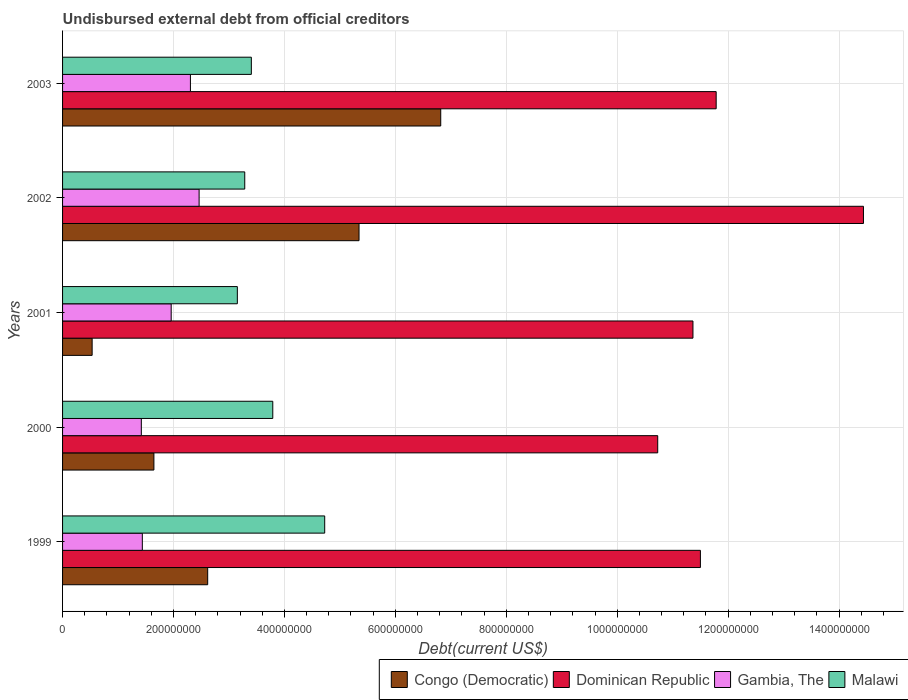How many different coloured bars are there?
Your answer should be very brief. 4. Are the number of bars per tick equal to the number of legend labels?
Provide a short and direct response. Yes. Are the number of bars on each tick of the Y-axis equal?
Provide a short and direct response. Yes. What is the label of the 3rd group of bars from the top?
Provide a short and direct response. 2001. What is the total debt in Dominican Republic in 1999?
Provide a short and direct response. 1.15e+09. Across all years, what is the maximum total debt in Congo (Democratic)?
Provide a succinct answer. 6.82e+08. Across all years, what is the minimum total debt in Malawi?
Keep it short and to the point. 3.15e+08. In which year was the total debt in Gambia, The minimum?
Offer a very short reply. 2000. What is the total total debt in Gambia, The in the graph?
Your answer should be compact. 9.58e+08. What is the difference between the total debt in Congo (Democratic) in 1999 and that in 2000?
Your response must be concise. 9.70e+07. What is the difference between the total debt in Gambia, The in 2000 and the total debt in Congo (Democratic) in 1999?
Make the answer very short. -1.20e+08. What is the average total debt in Congo (Democratic) per year?
Offer a very short reply. 3.39e+08. In the year 2001, what is the difference between the total debt in Gambia, The and total debt in Dominican Republic?
Your response must be concise. -9.41e+08. What is the ratio of the total debt in Congo (Democratic) in 1999 to that in 2003?
Keep it short and to the point. 0.38. Is the difference between the total debt in Gambia, The in 2000 and 2001 greater than the difference between the total debt in Dominican Republic in 2000 and 2001?
Make the answer very short. Yes. What is the difference between the highest and the second highest total debt in Malawi?
Ensure brevity in your answer.  9.36e+07. What is the difference between the highest and the lowest total debt in Gambia, The?
Offer a very short reply. 1.04e+08. Is it the case that in every year, the sum of the total debt in Congo (Democratic) and total debt in Dominican Republic is greater than the sum of total debt in Malawi and total debt in Gambia, The?
Keep it short and to the point. No. What does the 2nd bar from the top in 1999 represents?
Ensure brevity in your answer.  Gambia, The. What does the 4th bar from the bottom in 2001 represents?
Offer a very short reply. Malawi. Is it the case that in every year, the sum of the total debt in Malawi and total debt in Gambia, The is greater than the total debt in Dominican Republic?
Make the answer very short. No. How many bars are there?
Offer a terse response. 20. Are all the bars in the graph horizontal?
Provide a succinct answer. Yes. What is the difference between two consecutive major ticks on the X-axis?
Make the answer very short. 2.00e+08. Are the values on the major ticks of X-axis written in scientific E-notation?
Make the answer very short. No. Does the graph contain grids?
Provide a short and direct response. Yes. Where does the legend appear in the graph?
Give a very brief answer. Bottom right. What is the title of the graph?
Keep it short and to the point. Undisbursed external debt from official creditors. What is the label or title of the X-axis?
Give a very brief answer. Debt(current US$). What is the label or title of the Y-axis?
Your response must be concise. Years. What is the Debt(current US$) of Congo (Democratic) in 1999?
Your response must be concise. 2.62e+08. What is the Debt(current US$) in Dominican Republic in 1999?
Your answer should be compact. 1.15e+09. What is the Debt(current US$) of Gambia, The in 1999?
Give a very brief answer. 1.44e+08. What is the Debt(current US$) in Malawi in 1999?
Your answer should be very brief. 4.73e+08. What is the Debt(current US$) of Congo (Democratic) in 2000?
Your response must be concise. 1.65e+08. What is the Debt(current US$) in Dominican Republic in 2000?
Provide a short and direct response. 1.07e+09. What is the Debt(current US$) in Gambia, The in 2000?
Your answer should be very brief. 1.42e+08. What is the Debt(current US$) in Malawi in 2000?
Give a very brief answer. 3.79e+08. What is the Debt(current US$) of Congo (Democratic) in 2001?
Keep it short and to the point. 5.33e+07. What is the Debt(current US$) in Dominican Republic in 2001?
Your answer should be very brief. 1.14e+09. What is the Debt(current US$) in Gambia, The in 2001?
Your answer should be compact. 1.96e+08. What is the Debt(current US$) of Malawi in 2001?
Provide a short and direct response. 3.15e+08. What is the Debt(current US$) of Congo (Democratic) in 2002?
Give a very brief answer. 5.35e+08. What is the Debt(current US$) of Dominican Republic in 2002?
Provide a short and direct response. 1.44e+09. What is the Debt(current US$) of Gambia, The in 2002?
Provide a short and direct response. 2.46e+08. What is the Debt(current US$) of Malawi in 2002?
Ensure brevity in your answer.  3.28e+08. What is the Debt(current US$) in Congo (Democratic) in 2003?
Provide a short and direct response. 6.82e+08. What is the Debt(current US$) in Dominican Republic in 2003?
Your answer should be compact. 1.18e+09. What is the Debt(current US$) in Gambia, The in 2003?
Offer a terse response. 2.31e+08. What is the Debt(current US$) of Malawi in 2003?
Provide a succinct answer. 3.40e+08. Across all years, what is the maximum Debt(current US$) of Congo (Democratic)?
Offer a terse response. 6.82e+08. Across all years, what is the maximum Debt(current US$) in Dominican Republic?
Provide a succinct answer. 1.44e+09. Across all years, what is the maximum Debt(current US$) in Gambia, The?
Give a very brief answer. 2.46e+08. Across all years, what is the maximum Debt(current US$) in Malawi?
Give a very brief answer. 4.73e+08. Across all years, what is the minimum Debt(current US$) of Congo (Democratic)?
Your answer should be compact. 5.33e+07. Across all years, what is the minimum Debt(current US$) in Dominican Republic?
Your response must be concise. 1.07e+09. Across all years, what is the minimum Debt(current US$) of Gambia, The?
Your answer should be very brief. 1.42e+08. Across all years, what is the minimum Debt(current US$) in Malawi?
Give a very brief answer. 3.15e+08. What is the total Debt(current US$) in Congo (Democratic) in the graph?
Offer a very short reply. 1.70e+09. What is the total Debt(current US$) of Dominican Republic in the graph?
Your answer should be compact. 5.98e+09. What is the total Debt(current US$) in Gambia, The in the graph?
Keep it short and to the point. 9.58e+08. What is the total Debt(current US$) in Malawi in the graph?
Offer a terse response. 1.84e+09. What is the difference between the Debt(current US$) of Congo (Democratic) in 1999 and that in 2000?
Give a very brief answer. 9.70e+07. What is the difference between the Debt(current US$) in Dominican Republic in 1999 and that in 2000?
Make the answer very short. 7.70e+07. What is the difference between the Debt(current US$) in Gambia, The in 1999 and that in 2000?
Give a very brief answer. 1.81e+06. What is the difference between the Debt(current US$) of Malawi in 1999 and that in 2000?
Your answer should be compact. 9.36e+07. What is the difference between the Debt(current US$) in Congo (Democratic) in 1999 and that in 2001?
Give a very brief answer. 2.08e+08. What is the difference between the Debt(current US$) in Dominican Republic in 1999 and that in 2001?
Keep it short and to the point. 1.34e+07. What is the difference between the Debt(current US$) in Gambia, The in 1999 and that in 2001?
Your response must be concise. -5.20e+07. What is the difference between the Debt(current US$) of Malawi in 1999 and that in 2001?
Make the answer very short. 1.58e+08. What is the difference between the Debt(current US$) of Congo (Democratic) in 1999 and that in 2002?
Your response must be concise. -2.73e+08. What is the difference between the Debt(current US$) in Dominican Republic in 1999 and that in 2002?
Give a very brief answer. -2.94e+08. What is the difference between the Debt(current US$) in Gambia, The in 1999 and that in 2002?
Your response must be concise. -1.02e+08. What is the difference between the Debt(current US$) of Malawi in 1999 and that in 2002?
Provide a succinct answer. 1.44e+08. What is the difference between the Debt(current US$) in Congo (Democratic) in 1999 and that in 2003?
Make the answer very short. -4.20e+08. What is the difference between the Debt(current US$) of Dominican Republic in 1999 and that in 2003?
Your answer should be very brief. -2.84e+07. What is the difference between the Debt(current US$) in Gambia, The in 1999 and that in 2003?
Your response must be concise. -8.67e+07. What is the difference between the Debt(current US$) in Malawi in 1999 and that in 2003?
Your answer should be compact. 1.32e+08. What is the difference between the Debt(current US$) in Congo (Democratic) in 2000 and that in 2001?
Your answer should be compact. 1.11e+08. What is the difference between the Debt(current US$) of Dominican Republic in 2000 and that in 2001?
Provide a short and direct response. -6.35e+07. What is the difference between the Debt(current US$) in Gambia, The in 2000 and that in 2001?
Give a very brief answer. -5.39e+07. What is the difference between the Debt(current US$) in Malawi in 2000 and that in 2001?
Ensure brevity in your answer.  6.39e+07. What is the difference between the Debt(current US$) in Congo (Democratic) in 2000 and that in 2002?
Offer a terse response. -3.70e+08. What is the difference between the Debt(current US$) in Dominican Republic in 2000 and that in 2002?
Give a very brief answer. -3.71e+08. What is the difference between the Debt(current US$) of Gambia, The in 2000 and that in 2002?
Your response must be concise. -1.04e+08. What is the difference between the Debt(current US$) in Malawi in 2000 and that in 2002?
Provide a short and direct response. 5.05e+07. What is the difference between the Debt(current US$) in Congo (Democratic) in 2000 and that in 2003?
Offer a very short reply. -5.17e+08. What is the difference between the Debt(current US$) in Dominican Republic in 2000 and that in 2003?
Offer a very short reply. -1.05e+08. What is the difference between the Debt(current US$) of Gambia, The in 2000 and that in 2003?
Your answer should be very brief. -8.85e+07. What is the difference between the Debt(current US$) of Malawi in 2000 and that in 2003?
Give a very brief answer. 3.86e+07. What is the difference between the Debt(current US$) in Congo (Democratic) in 2001 and that in 2002?
Offer a terse response. -4.81e+08. What is the difference between the Debt(current US$) of Dominican Republic in 2001 and that in 2002?
Your answer should be very brief. -3.07e+08. What is the difference between the Debt(current US$) of Gambia, The in 2001 and that in 2002?
Keep it short and to the point. -5.03e+07. What is the difference between the Debt(current US$) of Malawi in 2001 and that in 2002?
Your answer should be very brief. -1.34e+07. What is the difference between the Debt(current US$) in Congo (Democratic) in 2001 and that in 2003?
Make the answer very short. -6.29e+08. What is the difference between the Debt(current US$) in Dominican Republic in 2001 and that in 2003?
Ensure brevity in your answer.  -4.19e+07. What is the difference between the Debt(current US$) in Gambia, The in 2001 and that in 2003?
Your answer should be compact. -3.47e+07. What is the difference between the Debt(current US$) in Malawi in 2001 and that in 2003?
Your answer should be compact. -2.52e+07. What is the difference between the Debt(current US$) of Congo (Democratic) in 2002 and that in 2003?
Provide a succinct answer. -1.47e+08. What is the difference between the Debt(current US$) in Dominican Republic in 2002 and that in 2003?
Make the answer very short. 2.66e+08. What is the difference between the Debt(current US$) in Gambia, The in 2002 and that in 2003?
Offer a terse response. 1.56e+07. What is the difference between the Debt(current US$) of Malawi in 2002 and that in 2003?
Provide a short and direct response. -1.19e+07. What is the difference between the Debt(current US$) of Congo (Democratic) in 1999 and the Debt(current US$) of Dominican Republic in 2000?
Offer a terse response. -8.11e+08. What is the difference between the Debt(current US$) in Congo (Democratic) in 1999 and the Debt(current US$) in Gambia, The in 2000?
Offer a terse response. 1.20e+08. What is the difference between the Debt(current US$) of Congo (Democratic) in 1999 and the Debt(current US$) of Malawi in 2000?
Give a very brief answer. -1.17e+08. What is the difference between the Debt(current US$) in Dominican Republic in 1999 and the Debt(current US$) in Gambia, The in 2000?
Make the answer very short. 1.01e+09. What is the difference between the Debt(current US$) of Dominican Republic in 1999 and the Debt(current US$) of Malawi in 2000?
Your answer should be compact. 7.71e+08. What is the difference between the Debt(current US$) in Gambia, The in 1999 and the Debt(current US$) in Malawi in 2000?
Make the answer very short. -2.35e+08. What is the difference between the Debt(current US$) of Congo (Democratic) in 1999 and the Debt(current US$) of Dominican Republic in 2001?
Keep it short and to the point. -8.75e+08. What is the difference between the Debt(current US$) in Congo (Democratic) in 1999 and the Debt(current US$) in Gambia, The in 2001?
Keep it short and to the point. 6.58e+07. What is the difference between the Debt(current US$) in Congo (Democratic) in 1999 and the Debt(current US$) in Malawi in 2001?
Your answer should be compact. -5.35e+07. What is the difference between the Debt(current US$) of Dominican Republic in 1999 and the Debt(current US$) of Gambia, The in 2001?
Your answer should be very brief. 9.54e+08. What is the difference between the Debt(current US$) of Dominican Republic in 1999 and the Debt(current US$) of Malawi in 2001?
Keep it short and to the point. 8.35e+08. What is the difference between the Debt(current US$) in Gambia, The in 1999 and the Debt(current US$) in Malawi in 2001?
Make the answer very short. -1.71e+08. What is the difference between the Debt(current US$) of Congo (Democratic) in 1999 and the Debt(current US$) of Dominican Republic in 2002?
Keep it short and to the point. -1.18e+09. What is the difference between the Debt(current US$) of Congo (Democratic) in 1999 and the Debt(current US$) of Gambia, The in 2002?
Keep it short and to the point. 1.55e+07. What is the difference between the Debt(current US$) of Congo (Democratic) in 1999 and the Debt(current US$) of Malawi in 2002?
Your answer should be compact. -6.68e+07. What is the difference between the Debt(current US$) in Dominican Republic in 1999 and the Debt(current US$) in Gambia, The in 2002?
Ensure brevity in your answer.  9.04e+08. What is the difference between the Debt(current US$) in Dominican Republic in 1999 and the Debt(current US$) in Malawi in 2002?
Provide a short and direct response. 8.22e+08. What is the difference between the Debt(current US$) of Gambia, The in 1999 and the Debt(current US$) of Malawi in 2002?
Provide a succinct answer. -1.85e+08. What is the difference between the Debt(current US$) in Congo (Democratic) in 1999 and the Debt(current US$) in Dominican Republic in 2003?
Your response must be concise. -9.17e+08. What is the difference between the Debt(current US$) of Congo (Democratic) in 1999 and the Debt(current US$) of Gambia, The in 2003?
Offer a very short reply. 3.11e+07. What is the difference between the Debt(current US$) of Congo (Democratic) in 1999 and the Debt(current US$) of Malawi in 2003?
Ensure brevity in your answer.  -7.87e+07. What is the difference between the Debt(current US$) of Dominican Republic in 1999 and the Debt(current US$) of Gambia, The in 2003?
Offer a terse response. 9.19e+08. What is the difference between the Debt(current US$) in Dominican Republic in 1999 and the Debt(current US$) in Malawi in 2003?
Provide a succinct answer. 8.10e+08. What is the difference between the Debt(current US$) of Gambia, The in 1999 and the Debt(current US$) of Malawi in 2003?
Give a very brief answer. -1.97e+08. What is the difference between the Debt(current US$) of Congo (Democratic) in 2000 and the Debt(current US$) of Dominican Republic in 2001?
Provide a succinct answer. -9.72e+08. What is the difference between the Debt(current US$) in Congo (Democratic) in 2000 and the Debt(current US$) in Gambia, The in 2001?
Your response must be concise. -3.12e+07. What is the difference between the Debt(current US$) in Congo (Democratic) in 2000 and the Debt(current US$) in Malawi in 2001?
Offer a very short reply. -1.50e+08. What is the difference between the Debt(current US$) of Dominican Republic in 2000 and the Debt(current US$) of Gambia, The in 2001?
Give a very brief answer. 8.77e+08. What is the difference between the Debt(current US$) in Dominican Republic in 2000 and the Debt(current US$) in Malawi in 2001?
Your answer should be very brief. 7.58e+08. What is the difference between the Debt(current US$) in Gambia, The in 2000 and the Debt(current US$) in Malawi in 2001?
Ensure brevity in your answer.  -1.73e+08. What is the difference between the Debt(current US$) of Congo (Democratic) in 2000 and the Debt(current US$) of Dominican Republic in 2002?
Your response must be concise. -1.28e+09. What is the difference between the Debt(current US$) in Congo (Democratic) in 2000 and the Debt(current US$) in Gambia, The in 2002?
Your answer should be compact. -8.15e+07. What is the difference between the Debt(current US$) of Congo (Democratic) in 2000 and the Debt(current US$) of Malawi in 2002?
Offer a terse response. -1.64e+08. What is the difference between the Debt(current US$) in Dominican Republic in 2000 and the Debt(current US$) in Gambia, The in 2002?
Give a very brief answer. 8.27e+08. What is the difference between the Debt(current US$) in Dominican Republic in 2000 and the Debt(current US$) in Malawi in 2002?
Give a very brief answer. 7.45e+08. What is the difference between the Debt(current US$) in Gambia, The in 2000 and the Debt(current US$) in Malawi in 2002?
Offer a terse response. -1.86e+08. What is the difference between the Debt(current US$) in Congo (Democratic) in 2000 and the Debt(current US$) in Dominican Republic in 2003?
Provide a short and direct response. -1.01e+09. What is the difference between the Debt(current US$) of Congo (Democratic) in 2000 and the Debt(current US$) of Gambia, The in 2003?
Ensure brevity in your answer.  -6.58e+07. What is the difference between the Debt(current US$) of Congo (Democratic) in 2000 and the Debt(current US$) of Malawi in 2003?
Your answer should be very brief. -1.76e+08. What is the difference between the Debt(current US$) of Dominican Republic in 2000 and the Debt(current US$) of Gambia, The in 2003?
Provide a short and direct response. 8.43e+08. What is the difference between the Debt(current US$) of Dominican Republic in 2000 and the Debt(current US$) of Malawi in 2003?
Your answer should be compact. 7.33e+08. What is the difference between the Debt(current US$) of Gambia, The in 2000 and the Debt(current US$) of Malawi in 2003?
Provide a short and direct response. -1.98e+08. What is the difference between the Debt(current US$) in Congo (Democratic) in 2001 and the Debt(current US$) in Dominican Republic in 2002?
Your answer should be very brief. -1.39e+09. What is the difference between the Debt(current US$) of Congo (Democratic) in 2001 and the Debt(current US$) of Gambia, The in 2002?
Ensure brevity in your answer.  -1.93e+08. What is the difference between the Debt(current US$) of Congo (Democratic) in 2001 and the Debt(current US$) of Malawi in 2002?
Keep it short and to the point. -2.75e+08. What is the difference between the Debt(current US$) of Dominican Republic in 2001 and the Debt(current US$) of Gambia, The in 2002?
Offer a terse response. 8.90e+08. What is the difference between the Debt(current US$) in Dominican Republic in 2001 and the Debt(current US$) in Malawi in 2002?
Offer a very short reply. 8.08e+08. What is the difference between the Debt(current US$) of Gambia, The in 2001 and the Debt(current US$) of Malawi in 2002?
Offer a terse response. -1.33e+08. What is the difference between the Debt(current US$) of Congo (Democratic) in 2001 and the Debt(current US$) of Dominican Republic in 2003?
Offer a very short reply. -1.13e+09. What is the difference between the Debt(current US$) of Congo (Democratic) in 2001 and the Debt(current US$) of Gambia, The in 2003?
Your answer should be compact. -1.77e+08. What is the difference between the Debt(current US$) in Congo (Democratic) in 2001 and the Debt(current US$) in Malawi in 2003?
Give a very brief answer. -2.87e+08. What is the difference between the Debt(current US$) in Dominican Republic in 2001 and the Debt(current US$) in Gambia, The in 2003?
Ensure brevity in your answer.  9.06e+08. What is the difference between the Debt(current US$) of Dominican Republic in 2001 and the Debt(current US$) of Malawi in 2003?
Offer a terse response. 7.96e+08. What is the difference between the Debt(current US$) of Gambia, The in 2001 and the Debt(current US$) of Malawi in 2003?
Your response must be concise. -1.45e+08. What is the difference between the Debt(current US$) in Congo (Democratic) in 2002 and the Debt(current US$) in Dominican Republic in 2003?
Give a very brief answer. -6.44e+08. What is the difference between the Debt(current US$) in Congo (Democratic) in 2002 and the Debt(current US$) in Gambia, The in 2003?
Offer a very short reply. 3.04e+08. What is the difference between the Debt(current US$) of Congo (Democratic) in 2002 and the Debt(current US$) of Malawi in 2003?
Your response must be concise. 1.94e+08. What is the difference between the Debt(current US$) of Dominican Republic in 2002 and the Debt(current US$) of Gambia, The in 2003?
Offer a terse response. 1.21e+09. What is the difference between the Debt(current US$) of Dominican Republic in 2002 and the Debt(current US$) of Malawi in 2003?
Ensure brevity in your answer.  1.10e+09. What is the difference between the Debt(current US$) of Gambia, The in 2002 and the Debt(current US$) of Malawi in 2003?
Give a very brief answer. -9.42e+07. What is the average Debt(current US$) of Congo (Democratic) per year?
Ensure brevity in your answer.  3.39e+08. What is the average Debt(current US$) of Dominican Republic per year?
Offer a very short reply. 1.20e+09. What is the average Debt(current US$) of Gambia, The per year?
Make the answer very short. 1.92e+08. What is the average Debt(current US$) in Malawi per year?
Ensure brevity in your answer.  3.67e+08. In the year 1999, what is the difference between the Debt(current US$) of Congo (Democratic) and Debt(current US$) of Dominican Republic?
Your response must be concise. -8.88e+08. In the year 1999, what is the difference between the Debt(current US$) in Congo (Democratic) and Debt(current US$) in Gambia, The?
Give a very brief answer. 1.18e+08. In the year 1999, what is the difference between the Debt(current US$) of Congo (Democratic) and Debt(current US$) of Malawi?
Your response must be concise. -2.11e+08. In the year 1999, what is the difference between the Debt(current US$) of Dominican Republic and Debt(current US$) of Gambia, The?
Your answer should be very brief. 1.01e+09. In the year 1999, what is the difference between the Debt(current US$) in Dominican Republic and Debt(current US$) in Malawi?
Give a very brief answer. 6.77e+08. In the year 1999, what is the difference between the Debt(current US$) in Gambia, The and Debt(current US$) in Malawi?
Your answer should be very brief. -3.29e+08. In the year 2000, what is the difference between the Debt(current US$) in Congo (Democratic) and Debt(current US$) in Dominican Republic?
Give a very brief answer. -9.08e+08. In the year 2000, what is the difference between the Debt(current US$) of Congo (Democratic) and Debt(current US$) of Gambia, The?
Your response must be concise. 2.27e+07. In the year 2000, what is the difference between the Debt(current US$) of Congo (Democratic) and Debt(current US$) of Malawi?
Your answer should be compact. -2.14e+08. In the year 2000, what is the difference between the Debt(current US$) in Dominican Republic and Debt(current US$) in Gambia, The?
Give a very brief answer. 9.31e+08. In the year 2000, what is the difference between the Debt(current US$) of Dominican Republic and Debt(current US$) of Malawi?
Your response must be concise. 6.94e+08. In the year 2000, what is the difference between the Debt(current US$) of Gambia, The and Debt(current US$) of Malawi?
Provide a short and direct response. -2.37e+08. In the year 2001, what is the difference between the Debt(current US$) of Congo (Democratic) and Debt(current US$) of Dominican Republic?
Your answer should be compact. -1.08e+09. In the year 2001, what is the difference between the Debt(current US$) in Congo (Democratic) and Debt(current US$) in Gambia, The?
Your answer should be very brief. -1.43e+08. In the year 2001, what is the difference between the Debt(current US$) of Congo (Democratic) and Debt(current US$) of Malawi?
Your response must be concise. -2.62e+08. In the year 2001, what is the difference between the Debt(current US$) of Dominican Republic and Debt(current US$) of Gambia, The?
Ensure brevity in your answer.  9.41e+08. In the year 2001, what is the difference between the Debt(current US$) in Dominican Republic and Debt(current US$) in Malawi?
Your answer should be very brief. 8.21e+08. In the year 2001, what is the difference between the Debt(current US$) of Gambia, The and Debt(current US$) of Malawi?
Offer a very short reply. -1.19e+08. In the year 2002, what is the difference between the Debt(current US$) in Congo (Democratic) and Debt(current US$) in Dominican Republic?
Your answer should be compact. -9.09e+08. In the year 2002, what is the difference between the Debt(current US$) in Congo (Democratic) and Debt(current US$) in Gambia, The?
Offer a very short reply. 2.88e+08. In the year 2002, what is the difference between the Debt(current US$) in Congo (Democratic) and Debt(current US$) in Malawi?
Offer a terse response. 2.06e+08. In the year 2002, what is the difference between the Debt(current US$) in Dominican Republic and Debt(current US$) in Gambia, The?
Offer a terse response. 1.20e+09. In the year 2002, what is the difference between the Debt(current US$) of Dominican Republic and Debt(current US$) of Malawi?
Ensure brevity in your answer.  1.12e+09. In the year 2002, what is the difference between the Debt(current US$) of Gambia, The and Debt(current US$) of Malawi?
Provide a succinct answer. -8.23e+07. In the year 2003, what is the difference between the Debt(current US$) of Congo (Democratic) and Debt(current US$) of Dominican Republic?
Provide a succinct answer. -4.97e+08. In the year 2003, what is the difference between the Debt(current US$) in Congo (Democratic) and Debt(current US$) in Gambia, The?
Offer a very short reply. 4.51e+08. In the year 2003, what is the difference between the Debt(current US$) of Congo (Democratic) and Debt(current US$) of Malawi?
Make the answer very short. 3.41e+08. In the year 2003, what is the difference between the Debt(current US$) in Dominican Republic and Debt(current US$) in Gambia, The?
Your answer should be compact. 9.48e+08. In the year 2003, what is the difference between the Debt(current US$) in Dominican Republic and Debt(current US$) in Malawi?
Your answer should be compact. 8.38e+08. In the year 2003, what is the difference between the Debt(current US$) of Gambia, The and Debt(current US$) of Malawi?
Your response must be concise. -1.10e+08. What is the ratio of the Debt(current US$) in Congo (Democratic) in 1999 to that in 2000?
Make the answer very short. 1.59. What is the ratio of the Debt(current US$) of Dominican Republic in 1999 to that in 2000?
Provide a succinct answer. 1.07. What is the ratio of the Debt(current US$) in Gambia, The in 1999 to that in 2000?
Provide a short and direct response. 1.01. What is the ratio of the Debt(current US$) of Malawi in 1999 to that in 2000?
Make the answer very short. 1.25. What is the ratio of the Debt(current US$) of Congo (Democratic) in 1999 to that in 2001?
Your answer should be very brief. 4.91. What is the ratio of the Debt(current US$) in Dominican Republic in 1999 to that in 2001?
Provide a short and direct response. 1.01. What is the ratio of the Debt(current US$) in Gambia, The in 1999 to that in 2001?
Give a very brief answer. 0.73. What is the ratio of the Debt(current US$) in Malawi in 1999 to that in 2001?
Give a very brief answer. 1.5. What is the ratio of the Debt(current US$) of Congo (Democratic) in 1999 to that in 2002?
Provide a short and direct response. 0.49. What is the ratio of the Debt(current US$) in Dominican Republic in 1999 to that in 2002?
Ensure brevity in your answer.  0.8. What is the ratio of the Debt(current US$) in Gambia, The in 1999 to that in 2002?
Provide a short and direct response. 0.58. What is the ratio of the Debt(current US$) of Malawi in 1999 to that in 2002?
Ensure brevity in your answer.  1.44. What is the ratio of the Debt(current US$) of Congo (Democratic) in 1999 to that in 2003?
Make the answer very short. 0.38. What is the ratio of the Debt(current US$) in Dominican Republic in 1999 to that in 2003?
Make the answer very short. 0.98. What is the ratio of the Debt(current US$) in Gambia, The in 1999 to that in 2003?
Ensure brevity in your answer.  0.62. What is the ratio of the Debt(current US$) of Malawi in 1999 to that in 2003?
Provide a short and direct response. 1.39. What is the ratio of the Debt(current US$) of Congo (Democratic) in 2000 to that in 2001?
Provide a short and direct response. 3.09. What is the ratio of the Debt(current US$) of Dominican Republic in 2000 to that in 2001?
Provide a succinct answer. 0.94. What is the ratio of the Debt(current US$) of Gambia, The in 2000 to that in 2001?
Your answer should be very brief. 0.72. What is the ratio of the Debt(current US$) of Malawi in 2000 to that in 2001?
Provide a succinct answer. 1.2. What is the ratio of the Debt(current US$) in Congo (Democratic) in 2000 to that in 2002?
Your answer should be very brief. 0.31. What is the ratio of the Debt(current US$) of Dominican Republic in 2000 to that in 2002?
Give a very brief answer. 0.74. What is the ratio of the Debt(current US$) in Gambia, The in 2000 to that in 2002?
Make the answer very short. 0.58. What is the ratio of the Debt(current US$) of Malawi in 2000 to that in 2002?
Your answer should be compact. 1.15. What is the ratio of the Debt(current US$) in Congo (Democratic) in 2000 to that in 2003?
Offer a very short reply. 0.24. What is the ratio of the Debt(current US$) in Dominican Republic in 2000 to that in 2003?
Make the answer very short. 0.91. What is the ratio of the Debt(current US$) of Gambia, The in 2000 to that in 2003?
Keep it short and to the point. 0.62. What is the ratio of the Debt(current US$) in Malawi in 2000 to that in 2003?
Your answer should be compact. 1.11. What is the ratio of the Debt(current US$) of Congo (Democratic) in 2001 to that in 2002?
Offer a terse response. 0.1. What is the ratio of the Debt(current US$) in Dominican Republic in 2001 to that in 2002?
Ensure brevity in your answer.  0.79. What is the ratio of the Debt(current US$) in Gambia, The in 2001 to that in 2002?
Your answer should be compact. 0.8. What is the ratio of the Debt(current US$) of Malawi in 2001 to that in 2002?
Offer a very short reply. 0.96. What is the ratio of the Debt(current US$) of Congo (Democratic) in 2001 to that in 2003?
Provide a short and direct response. 0.08. What is the ratio of the Debt(current US$) in Dominican Republic in 2001 to that in 2003?
Your response must be concise. 0.96. What is the ratio of the Debt(current US$) in Gambia, The in 2001 to that in 2003?
Make the answer very short. 0.85. What is the ratio of the Debt(current US$) of Malawi in 2001 to that in 2003?
Provide a succinct answer. 0.93. What is the ratio of the Debt(current US$) of Congo (Democratic) in 2002 to that in 2003?
Provide a short and direct response. 0.78. What is the ratio of the Debt(current US$) in Dominican Republic in 2002 to that in 2003?
Offer a terse response. 1.23. What is the ratio of the Debt(current US$) of Gambia, The in 2002 to that in 2003?
Your answer should be very brief. 1.07. What is the ratio of the Debt(current US$) in Malawi in 2002 to that in 2003?
Provide a short and direct response. 0.97. What is the difference between the highest and the second highest Debt(current US$) of Congo (Democratic)?
Ensure brevity in your answer.  1.47e+08. What is the difference between the highest and the second highest Debt(current US$) in Dominican Republic?
Your response must be concise. 2.66e+08. What is the difference between the highest and the second highest Debt(current US$) in Gambia, The?
Your answer should be compact. 1.56e+07. What is the difference between the highest and the second highest Debt(current US$) in Malawi?
Your response must be concise. 9.36e+07. What is the difference between the highest and the lowest Debt(current US$) of Congo (Democratic)?
Give a very brief answer. 6.29e+08. What is the difference between the highest and the lowest Debt(current US$) in Dominican Republic?
Make the answer very short. 3.71e+08. What is the difference between the highest and the lowest Debt(current US$) of Gambia, The?
Your answer should be very brief. 1.04e+08. What is the difference between the highest and the lowest Debt(current US$) of Malawi?
Your answer should be very brief. 1.58e+08. 